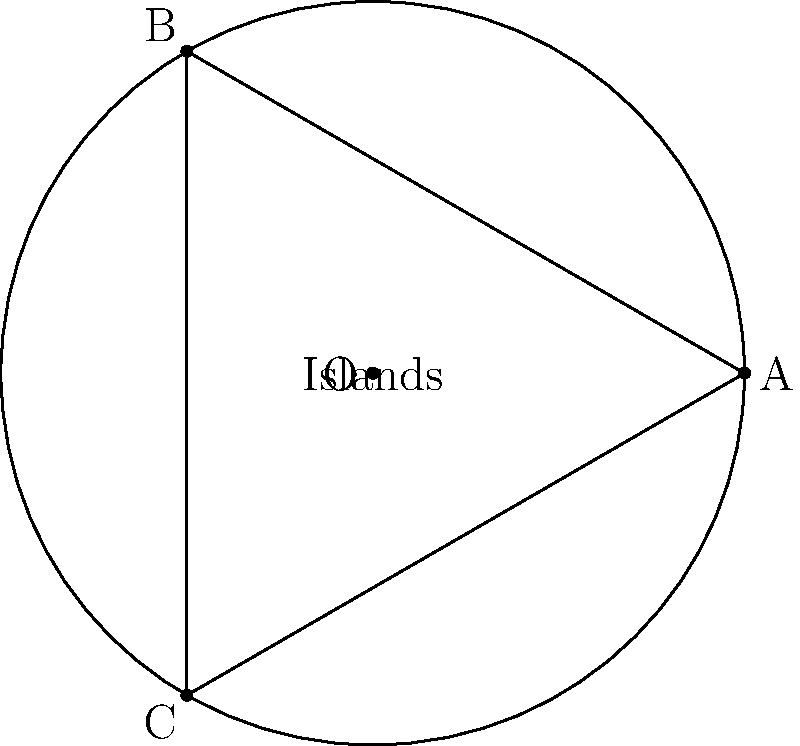A circular shipping route passes through points A, B, and C, which form an equilateral triangle inscribed in the circle. The distance between any two of these points is 90 nautical miles. Calculate the total length of the circular shipping route in nautical miles. To solve this problem, we'll follow these steps:

1) First, we need to find the radius of the circle. We can do this using the properties of an equilateral triangle inscribed in a circle.

2) In an equilateral triangle, the length of a side (s) is related to the radius (r) of the circumscribed circle by the formula:

   $$s = r\sqrt{3}$$

3) We're given that the side length (distance between any two points) is 90 nautical miles. Let's substitute this into our formula:

   $$90 = r\sqrt{3}$$

4) Solving for r:

   $$r = \frac{90}{\sqrt{3}} = 90 \cdot \frac{\sqrt{3}}{3} \approx 51.96$$ nautical miles

5) Now that we have the radius, we can calculate the circumference of the circle using the formula:

   $$C = 2\pi r$$

6) Substituting our radius:

   $$C = 2\pi \cdot \frac{90\sqrt{3}}{3} = 60\pi\sqrt{3} \approx 326.73$$ nautical miles

Therefore, the total length of the circular shipping route is approximately 326.73 nautical miles.
Answer: $60\pi\sqrt{3}$ nautical miles 